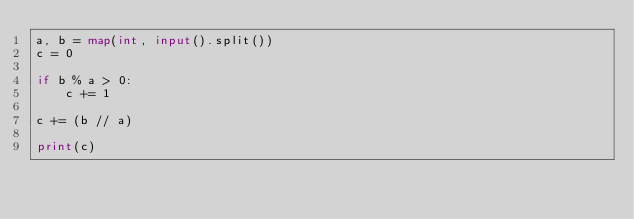Convert code to text. <code><loc_0><loc_0><loc_500><loc_500><_Python_>a, b = map(int, input().split())
c = 0

if b % a > 0:
    c += 1

c += (b // a)

print(c)</code> 